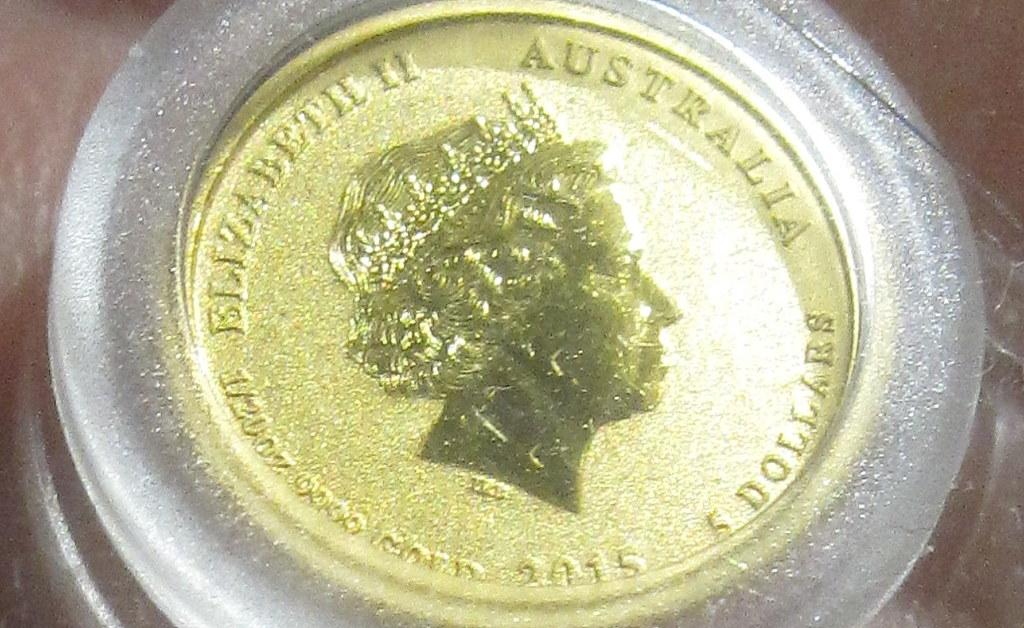<image>
Relay a brief, clear account of the picture shown. Gold Elizabeth of Australia in a plastic case the words 2015. 